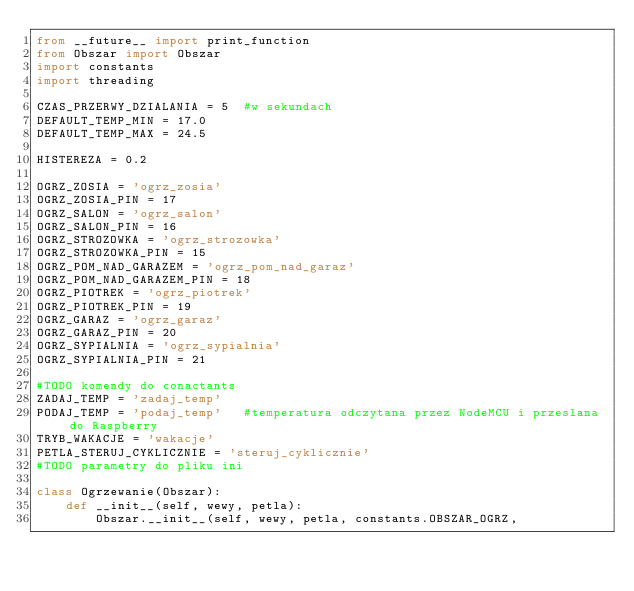Convert code to text. <code><loc_0><loc_0><loc_500><loc_500><_Python_>from __future__ import print_function
from Obszar import Obszar
import constants
import threading

CZAS_PRZERWY_DZIALANIA = 5  #w sekundach
DEFAULT_TEMP_MIN = 17.0
DEFAULT_TEMP_MAX = 24.5

HISTEREZA = 0.2

OGRZ_ZOSIA = 'ogrz_zosia'
OGRZ_ZOSIA_PIN = 17
OGRZ_SALON = 'ogrz_salon'
OGRZ_SALON_PIN = 16
OGRZ_STROZOWKA = 'ogrz_strozowka'
OGRZ_STROZOWKA_PIN = 15
OGRZ_POM_NAD_GARAZEM = 'ogrz_pom_nad_garaz'
OGRZ_POM_NAD_GARAZEM_PIN = 18
OGRZ_PIOTREK = 'ogrz_piotrek'
OGRZ_PIOTREK_PIN = 19
OGRZ_GARAZ = 'ogrz_garaz'
OGRZ_GARAZ_PIN = 20
OGRZ_SYPIALNIA = 'ogrz_sypialnia'
OGRZ_SYPIALNIA_PIN = 21

#TODO komendy do conactants
ZADAJ_TEMP = 'zadaj_temp'
PODAJ_TEMP = 'podaj_temp'   #temperatura odczytana przez NodeMCU i przeslana do Raspberry
TRYB_WAKACJE = 'wakacje'
PETLA_STERUJ_CYKLICZNIE = 'steruj_cyklicznie'
#TODO parametry do pliku ini

class Ogrzewanie(Obszar):
    def __init__(self, wewy, petla):
        Obszar.__init__(self, wewy, petla, constants.OBSZAR_OGRZ,</code> 